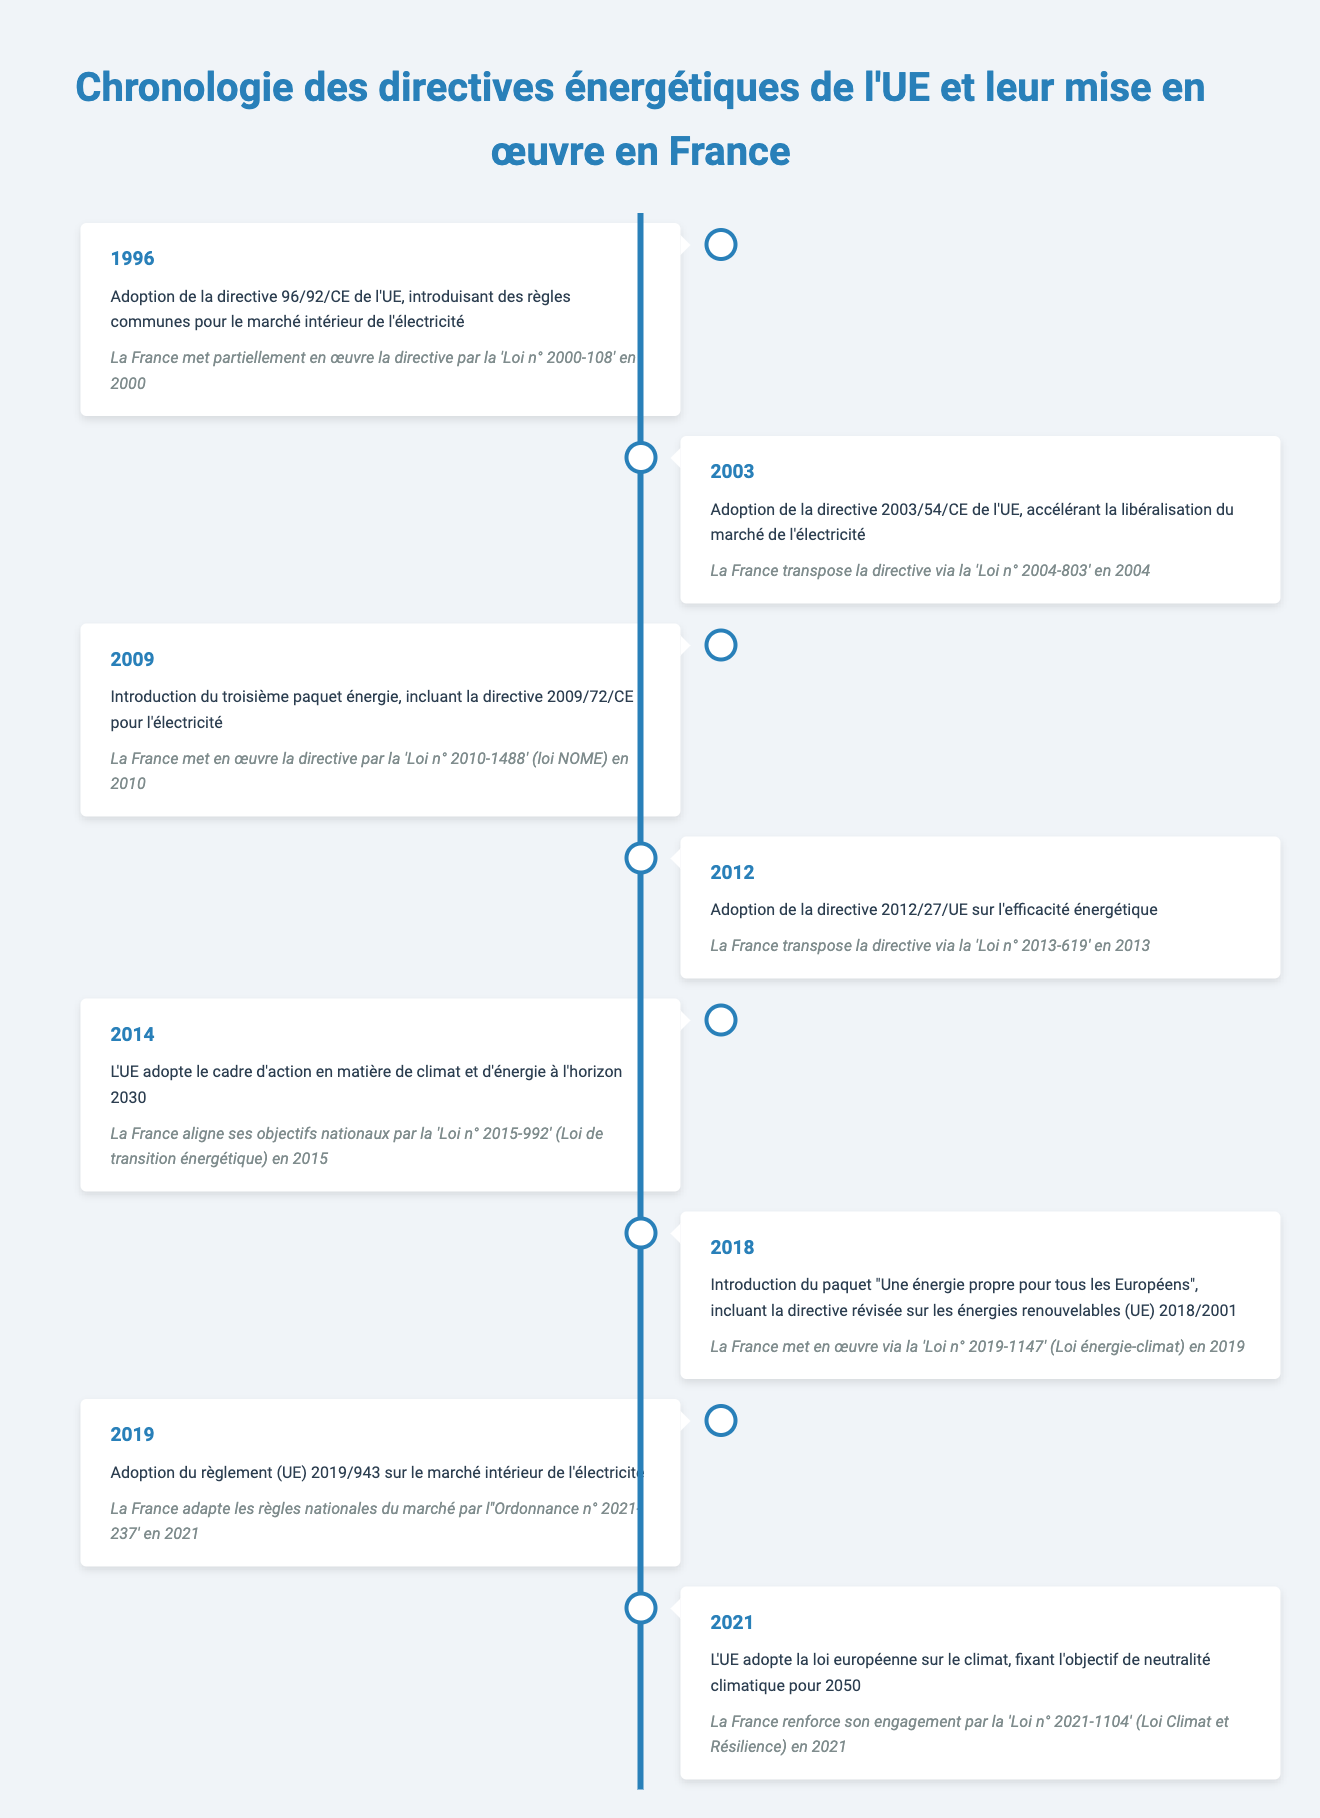What year was the EU Directive 2003/54/EC adopted? The table directly states that the event occurred in the year 2003, which is explicitly mentioned in the entry related to this directive.
Answer: 2003 Which directive did France implement through 'Loi n° 2010-1488'? According to the table, France implemented the Third Energy Package, specifically Directive 2009/72/EC for electricity, through 'Loi n° 2010-1488' in 2010.
Answer: Directive 2009/72/EC Did France implement any European directives in 2019? The entries in the table confirm that 2019 saw the implementation of the revised Renewable Energy Directive and adaptations to national market rules, indicating that France did indeed implement directives that year.
Answer: Yes How many years separated the adoption of EU Energy Efficiency Directive 2012/27/EU and the implementation of the 2030 Climate and Energy Framework by France? The EU Energy Efficiency Directive was adopted in 2012 and implemented in France through 'Loi n° 2013-619', and the 2030 Climate and Energy Framework was adopted in 2014 and implemented in 2015. The time difference is 2015 - 2012 = 3 years.
Answer: 3 years What was the first directive mentioned in the timeline, and in what year was it adopted? The first directive mentioned in the timeline is EU Directive 96/92/EC, which was adopted in 1996 as per the historic data provided in the table.
Answer: EU Directive 96/92/EC; 1996 What is the last event listed in the timeline regarding EU energy directives? The last event in the timeline is the adoption of the European Climate Law, setting the 2050 climate neutrality target, which was adopted in 2021.
Answer: Adoption of the European Climate Law; 2021 How many directives did France implement after the year 2010 and before 2021? The table outlines the directives implemented by France after 2010 until 2021, totaling four directives: the Energy Efficiency Directive in 2013, the Climate and Energy Framework in 2015, the Renewable Energy Directive in 2019, and adjustments to market rules in 2021. Therefore, the count is 4.
Answer: 4 Did France implement the Clean Energy for All Europeans package in 2019? Yes, the table indicates that France implemented the package via 'Loi n° 2019-1147' (Energy-Climate Law) in 2019, confirming that this implementation occurred.
Answer: Yes 